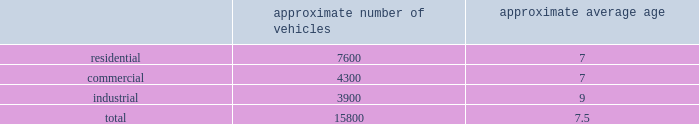Standardized maintenance based on an industry trade publication , we operate the eighth largest vocational fleet in the united states .
As of december 31 , 2014 , our average fleet age in years , by line of business , was as follows : approximate number of vehicles approximate average age .
Through standardization of core functions , we believe we can minimize variability in our maintenance processes resulting in higher vehicle quality while extending the service life of our fleet .
We believe operating a more reliable , safer and efficient fleet will lower our operating costs .
We have implemented standardized maintenance programs for approximately 60% ( 60 % ) of our fleet maintenance operations as of december 31 , 2014 .
Cash utilization strategy key components of our cash utilization strategy include increasing free cash flow and improving our return on invested capital .
Our definition of free cash flow , which is not a measure determined in accordance with united states generally accepted accounting principles ( u.s .
Gaap ) , is cash provided by operating activities less purchases of property and equipment , plus proceeds from sales of property and equipment as presented in our consolidated statements of cash flows .
For a discussion and reconciliation of free cash flow , you should read the 201cfree cash flow 201d section of our management 2019s discussion and analysis of financial condition and results of operations contained in item 7 of this form 10-k .
We believe free cash flow drives shareholder value and provides useful information regarding the recurring cash provided by our operations .
Free cash flow also demonstrates our ability to execute our cash utilization strategy , which includes investments in acquisitions and returning a majority of free cash flow to our shareholders through dividends and share repurchases .
We are committed to an efficient capital structure and maintaining our investment grade credit ratings .
We manage our free cash flow by ensuring that capital expenditures and operating asset levels are appropriate in light of our existing business and growth opportunities , and by closely managing our working capital , which consists primarily of accounts receivable , accounts payable , and accrued landfill and environmental costs .
Dividends in july 2003 , our board of directors initiated a quarterly cash dividend of $ 0.04 per share .
Our quarterly dividend has increased from time to time thereafter , the latest increase occurring in july 2014 to $ 0.28 per share , representing a 7.7% ( 7.7 % ) increase over that of the prior year .
Over the last 5 years , our dividend has increased at a compounded annual growth rate of 8.1% ( 8.1 % ) .
We expect to continue paying quarterly cash dividends and may consider additional dividend increases if we believe they will enhance shareholder value .
Share repurchases in october 2013 , our board of directors added $ 650 million to the existing share repurchase authorization originally approved in november 2010 .
From november 2010 to december 31 , 2014 , we used $ 1439.5 million to repurchase 46.6 million shares of our common stock at a weighted average cost per share of $ 30.88 .
As of december 31 , 2014 , there were $ 360.2 million remaining under our share repurchase authorization .
During 2015 , we expect to use our remaining authorization to repurchase more of our outstanding common stock. .
What is the percent of the residential vehicles as part of the fleet? 
Rationale: to get the percent of the residential you divide the residential by the total
Computations: (7600 / 15800)
Answer: 0.48101. 